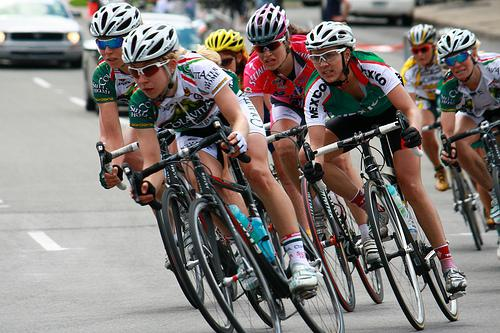Question: how many bikers are in this photo?
Choices:
A. 7.
B. 8.
C. 9.
D. 10.
Answer with the letter. Answer: A Question: what are the bikers wearing on their heads?
Choices:
A. Helmets.
B. Masks.
C. Hats.
D. Berets.
Answer with the letter. Answer: A Question: what event is this?
Choices:
A. Concert.
B. Bike race.
C. Comedy show.
D. Circus.
Answer with the letter. Answer: B Question: where are they riding?
Choices:
A. Ranch.
B. Beach.
C. Street.
D. Zoo.
Answer with the letter. Answer: C Question: what are they wearing on their eyes?
Choices:
A. Prescription glasses.
B. Sunglasses.
C. Goggles.
D. Binoculars.
Answer with the letter. Answer: B 